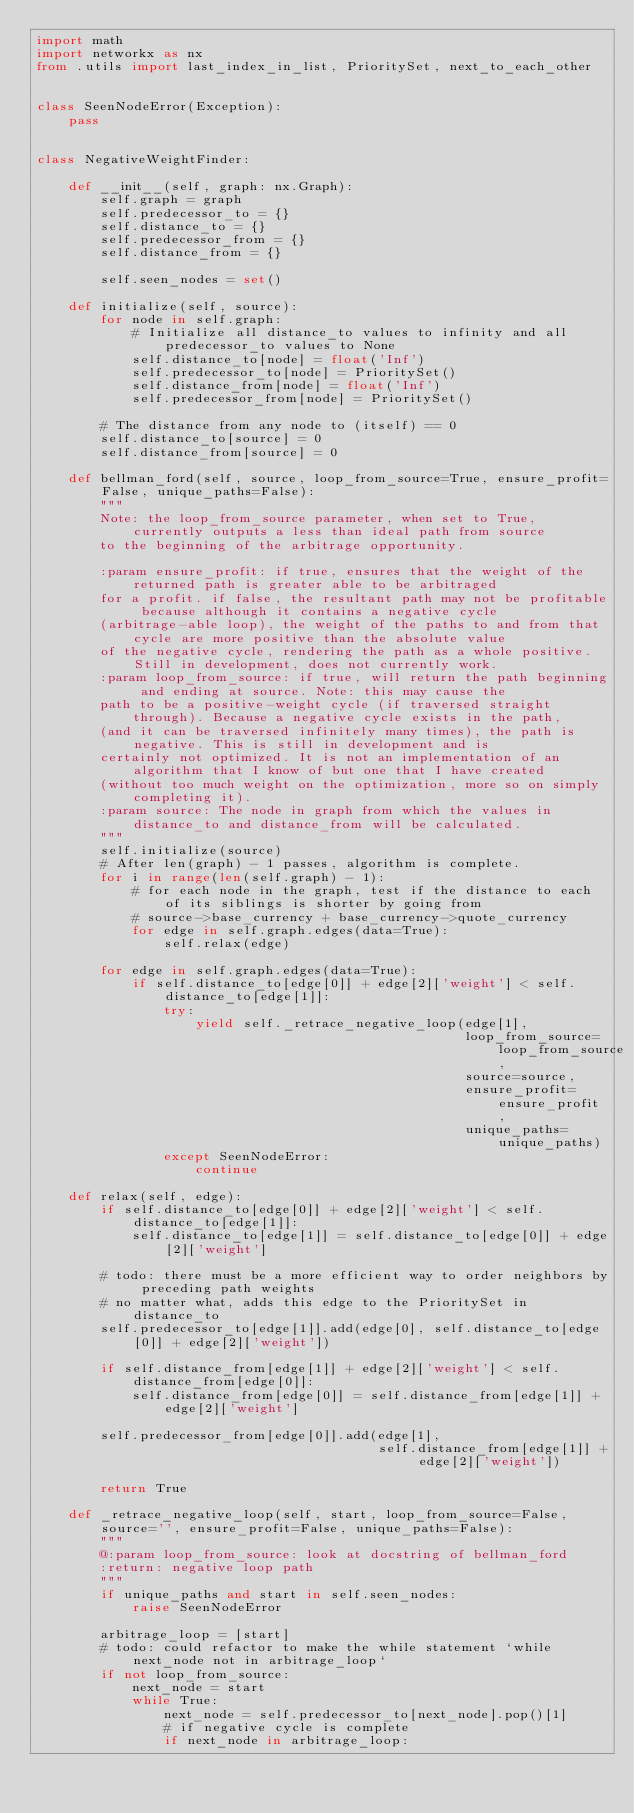<code> <loc_0><loc_0><loc_500><loc_500><_Python_>import math
import networkx as nx
from .utils import last_index_in_list, PrioritySet, next_to_each_other


class SeenNodeError(Exception):
    pass


class NegativeWeightFinder:

    def __init__(self, graph: nx.Graph):
        self.graph = graph
        self.predecessor_to = {}
        self.distance_to = {}
        self.predecessor_from = {}
        self.distance_from = {}

        self.seen_nodes = set()
    
    def initialize(self, source):
        for node in self.graph:
            # Initialize all distance_to values to infinity and all predecessor_to values to None
            self.distance_to[node] = float('Inf')
            self.predecessor_to[node] = PrioritySet()
            self.distance_from[node] = float('Inf')
            self.predecessor_from[node] = PrioritySet()

        # The distance from any node to (itself) == 0
        self.distance_to[source] = 0
        self.distance_from[source] = 0

    def bellman_ford(self, source, loop_from_source=True, ensure_profit=False, unique_paths=False):
        """
        Note: the loop_from_source parameter, when set to True, currently outputs a less than ideal path from source
        to the beginning of the arbitrage opportunity.
        
        :param ensure_profit: if true, ensures that the weight of the returned path is greater able to be arbitraged
        for a profit. if false, the resultant path may not be profitable because although it contains a negative cycle
        (arbitrage-able loop), the weight of the paths to and from that cycle are more positive than the absolute value
        of the negative cycle, rendering the path as a whole positive. Still in development, does not currently work.
        :param loop_from_source: if true, will return the path beginning and ending at source. Note: this may cause the
        path to be a positive-weight cycle (if traversed straight through). Because a negative cycle exists in the path,
        (and it can be traversed infinitely many times), the path is negative. This is still in development and is
        certainly not optimized. It is not an implementation of an algorithm that I know of but one that I have created
        (without too much weight on the optimization, more so on simply completing it).
        :param source: The node in graph from which the values in distance_to and distance_from will be calculated.
        """
        self.initialize(source)
        # After len(graph) - 1 passes, algorithm is complete.
        for i in range(len(self.graph) - 1):
            # for each node in the graph, test if the distance to each of its siblings is shorter by going from
            # source->base_currency + base_currency->quote_currency
            for edge in self.graph.edges(data=True):
                self.relax(edge)

        for edge in self.graph.edges(data=True):
            if self.distance_to[edge[0]] + edge[2]['weight'] < self.distance_to[edge[1]]:
                try:
                    yield self._retrace_negative_loop(edge[1],
                                                      loop_from_source=loop_from_source,
                                                      source=source,
                                                      ensure_profit=ensure_profit,
                                                      unique_paths=unique_paths)
                except SeenNodeError:
                    continue

    def relax(self, edge):
        if self.distance_to[edge[0]] + edge[2]['weight'] < self.distance_to[edge[1]]:
            self.distance_to[edge[1]] = self.distance_to[edge[0]] + edge[2]['weight']

        # todo: there must be a more efficient way to order neighbors by preceding path weights
        # no matter what, adds this edge to the PrioritySet in distance_to
        self.predecessor_to[edge[1]].add(edge[0], self.distance_to[edge[0]] + edge[2]['weight'])

        if self.distance_from[edge[1]] + edge[2]['weight'] < self.distance_from[edge[0]]:
            self.distance_from[edge[0]] = self.distance_from[edge[1]] + edge[2]['weight']

        self.predecessor_from[edge[0]].add(edge[1],
                                           self.distance_from[edge[1]] + edge[2]['weight'])

        return True

    def _retrace_negative_loop(self, start, loop_from_source=False, source='', ensure_profit=False, unique_paths=False):
        """
        @:param loop_from_source: look at docstring of bellman_ford
        :return: negative loop path
        """
        if unique_paths and start in self.seen_nodes:
            raise SeenNodeError

        arbitrage_loop = [start]
        # todo: could refactor to make the while statement `while next_node not in arbitrage_loop`
        if not loop_from_source:
            next_node = start
            while True:
                next_node = self.predecessor_to[next_node].pop()[1]
                # if negative cycle is complete
                if next_node in arbitrage_loop:</code> 